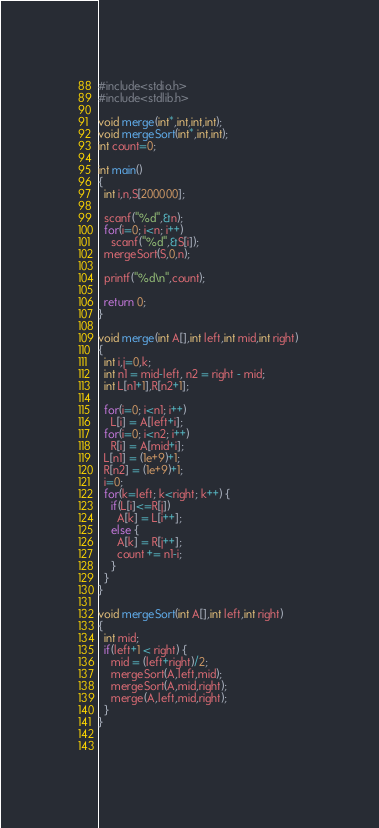Convert code to text. <code><loc_0><loc_0><loc_500><loc_500><_C_>#include<stdio.h>
#include<stdlib.h>

void merge(int*,int,int,int);
void mergeSort(int*,int,int);
int count=0;

int main() 
{
  int i,n,S[200000];
 
  scanf("%d",&n);
  for(i=0; i<n; i++) 
    scanf("%d",&S[i]);
  mergeSort(S,0,n);
 
  printf("%d\n",count);
  
  return 0;
}

void merge(int A[],int left,int mid,int right) 
{
  int i,j=0,k;
  int n1 = mid-left, n2 = right - mid; 
  int L[n1+1],R[n2+1];
  
  for(i=0; i<n1; i++) 
    L[i] = A[left+i];
  for(i=0; i<n2; i++) 
    R[i] = A[mid+i];
  L[n1] = (1e+9)+1;
  R[n2] = (1e+9)+1;
  i=0;
  for(k=left; k<right; k++) {
    if(L[i]<=R[j])
      A[k] = L[i++];
    else {
      A[k] = R[j++];
      count += n1-i;
    }
  }
}

void mergeSort(int A[],int left,int right) 
{
  int mid;
  if(left+1 < right) {
    mid = (left+right)/2;
    mergeSort(A,left,mid);
    mergeSort(A,mid,right);
    merge(A,left,mid,right);
  }
}
  
  </code> 